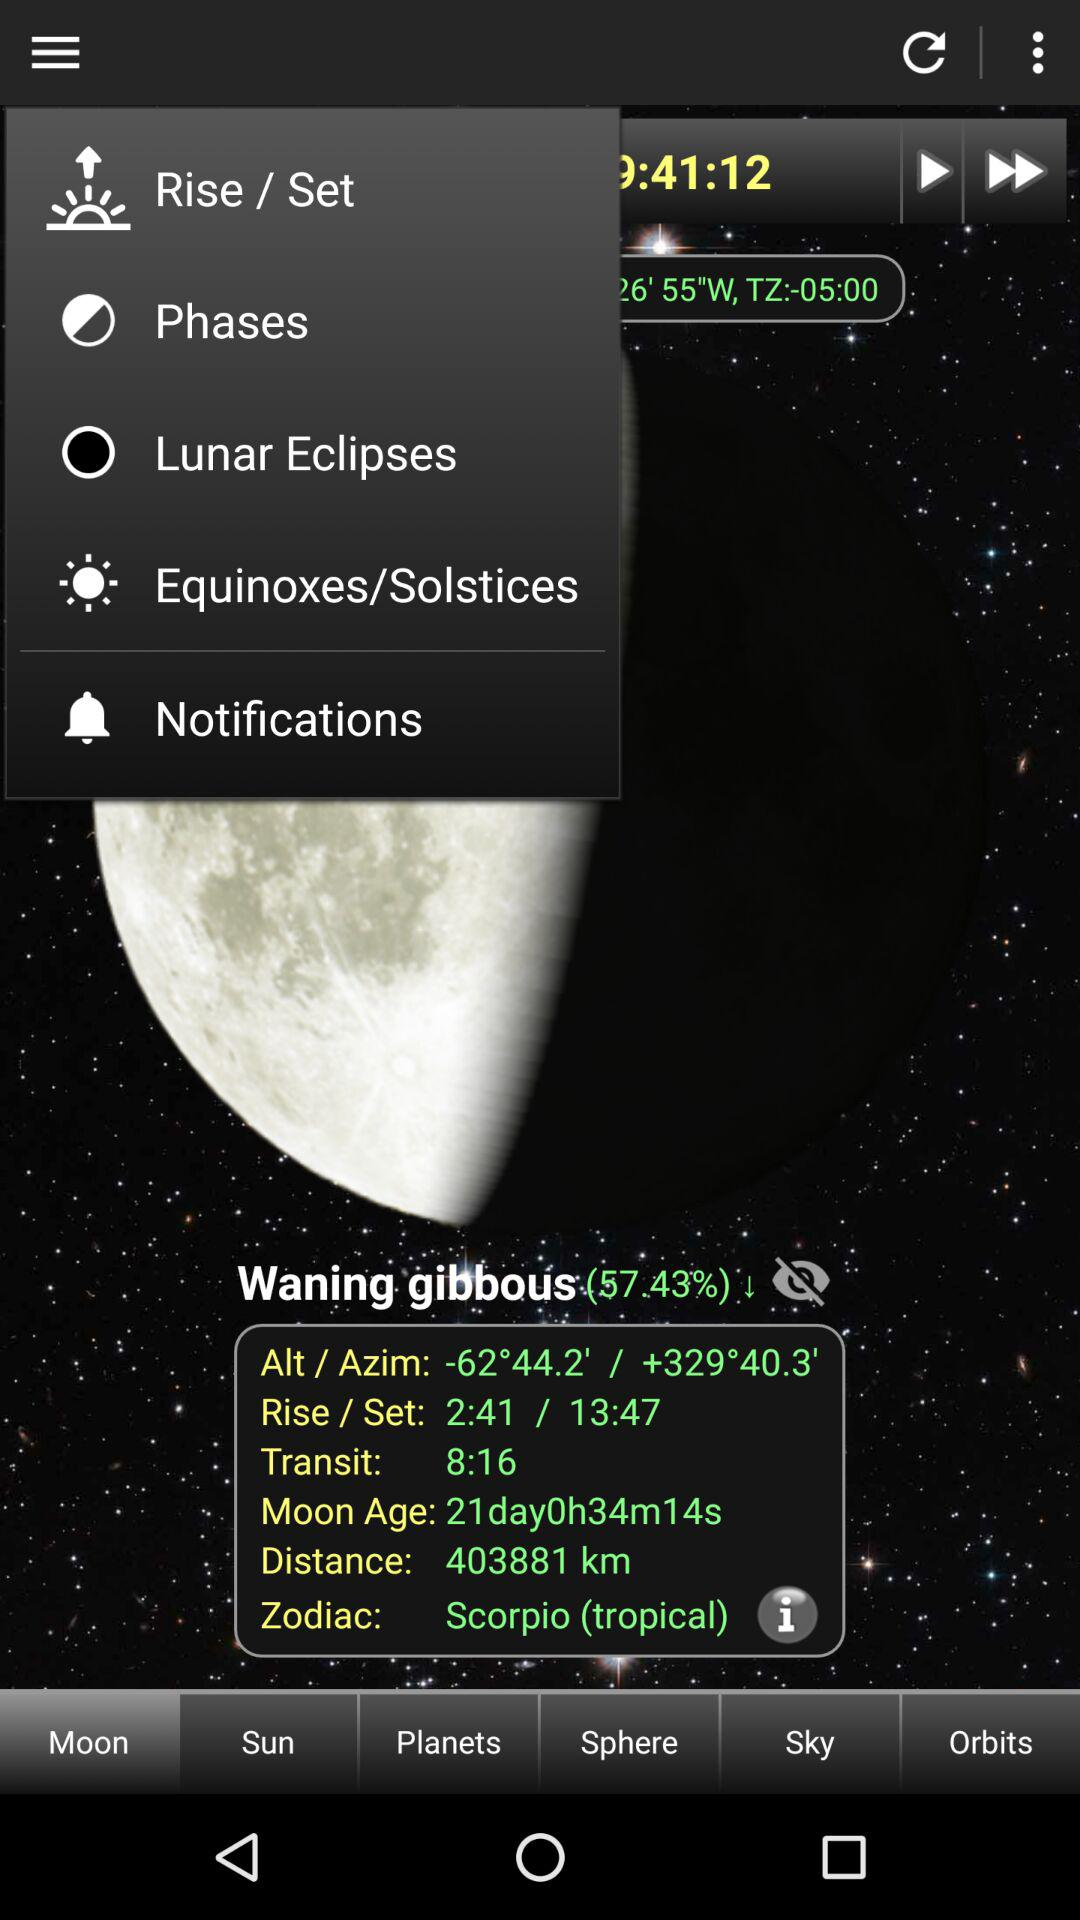What is the distance? The distance is 403881 km. 